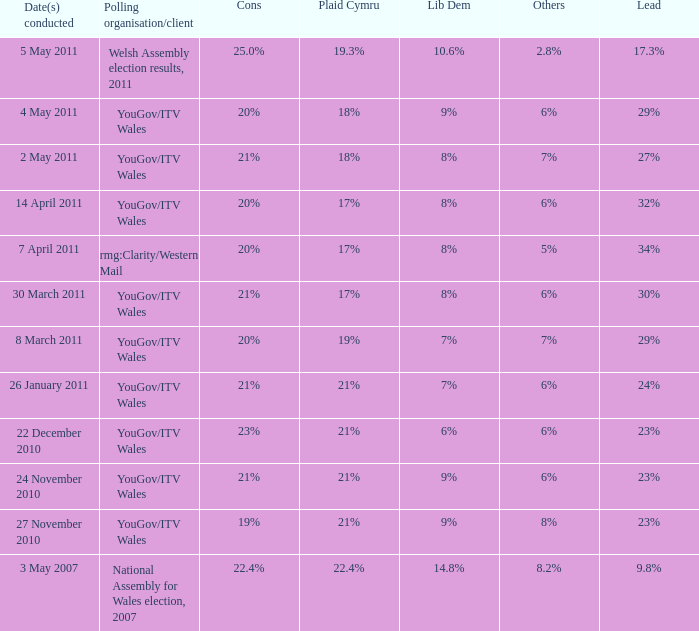Name the others for cons of 21% and lead of 24% 6%. 